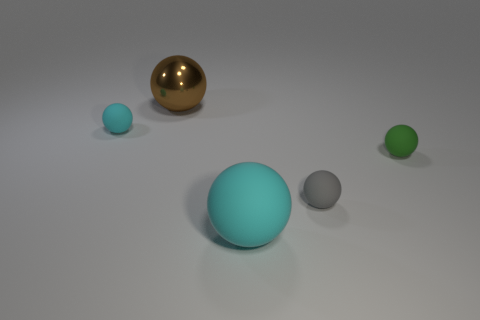Subtract all small cyan balls. How many balls are left? 4 Add 5 green matte spheres. How many objects exist? 10 Subtract 1 balls. How many balls are left? 4 Subtract all brown balls. How many balls are left? 4 Subtract all cyan cubes. How many blue balls are left? 0 Subtract all small gray things. Subtract all big brown matte cylinders. How many objects are left? 4 Add 2 small gray rubber things. How many small gray rubber things are left? 3 Add 4 small cyan rubber things. How many small cyan rubber things exist? 5 Subtract 0 blue cubes. How many objects are left? 5 Subtract all gray spheres. Subtract all cyan cylinders. How many spheres are left? 4 